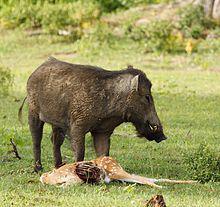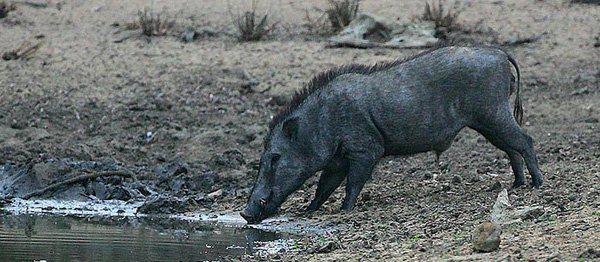The first image is the image on the left, the second image is the image on the right. Assess this claim about the two images: "There are two wild pigs out in the wild.". Correct or not? Answer yes or no. Yes. The first image is the image on the left, the second image is the image on the right. Considering the images on both sides, is "An image shows one wild pig with the carcass of a spotted hooved animal." valid? Answer yes or no. Yes. 